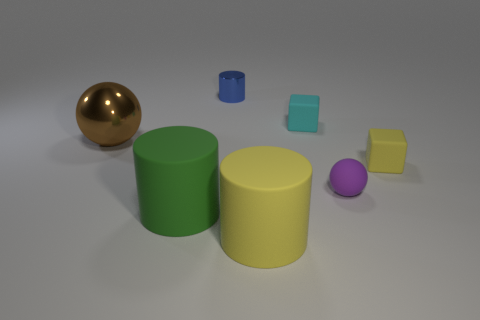Add 3 large blue cylinders. How many objects exist? 10 Subtract all cubes. How many objects are left? 5 Add 5 matte cylinders. How many matte cylinders exist? 7 Subtract 0 green balls. How many objects are left? 7 Subtract all metal spheres. Subtract all tiny yellow balls. How many objects are left? 6 Add 4 big green matte things. How many big green matte things are left? 5 